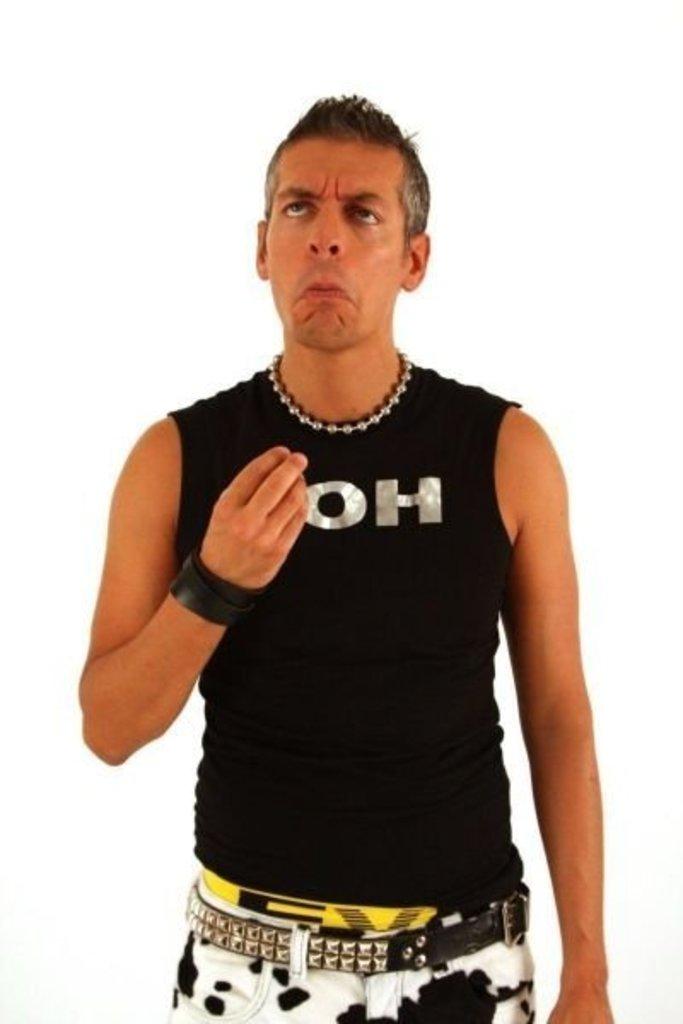What two letter word can be clearly seen on this shirt?
Your response must be concise. Oh. 